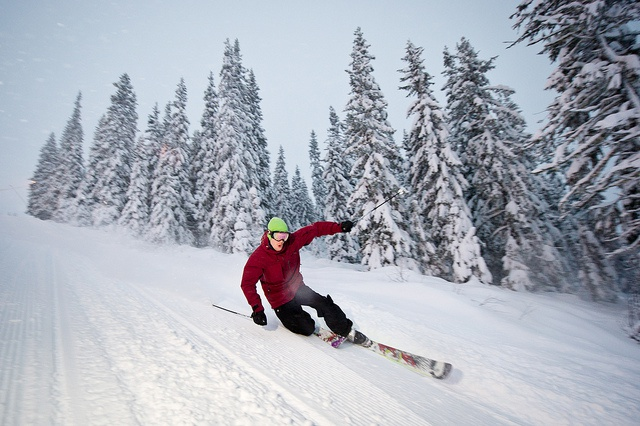Describe the objects in this image and their specific colors. I can see people in darkgray, maroon, black, gray, and brown tones and skis in darkgray, lightgray, gray, and brown tones in this image. 